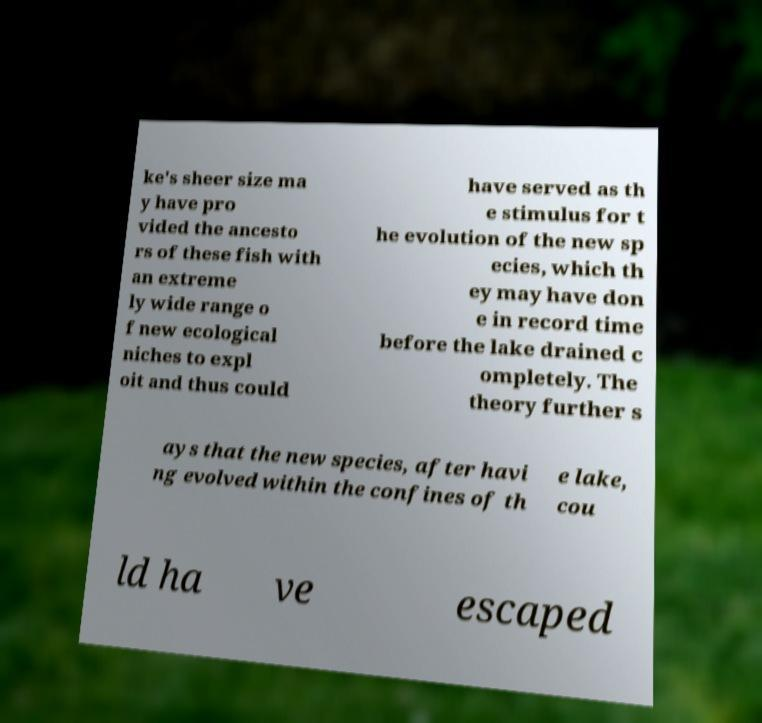Can you read and provide the text displayed in the image?This photo seems to have some interesting text. Can you extract and type it out for me? ke's sheer size ma y have pro vided the ancesto rs of these fish with an extreme ly wide range o f new ecological niches to expl oit and thus could have served as th e stimulus for t he evolution of the new sp ecies, which th ey may have don e in record time before the lake drained c ompletely. The theory further s ays that the new species, after havi ng evolved within the confines of th e lake, cou ld ha ve escaped 